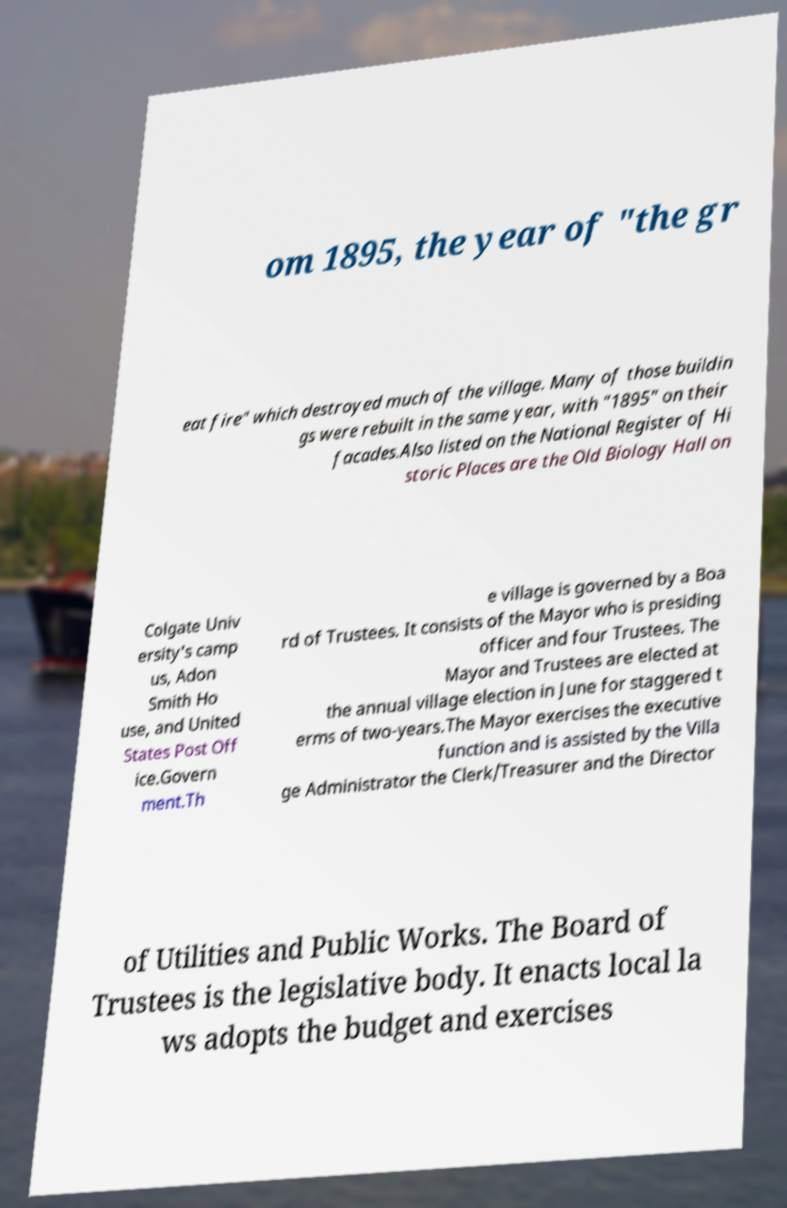What messages or text are displayed in this image? I need them in a readable, typed format. om 1895, the year of "the gr eat fire" which destroyed much of the village. Many of those buildin gs were rebuilt in the same year, with "1895" on their facades.Also listed on the National Register of Hi storic Places are the Old Biology Hall on Colgate Univ ersity's camp us, Adon Smith Ho use, and United States Post Off ice.Govern ment.Th e village is governed by a Boa rd of Trustees. It consists of the Mayor who is presiding officer and four Trustees. The Mayor and Trustees are elected at the annual village election in June for staggered t erms of two-years.The Mayor exercises the executive function and is assisted by the Villa ge Administrator the Clerk/Treasurer and the Director of Utilities and Public Works. The Board of Trustees is the legislative body. It enacts local la ws adopts the budget and exercises 